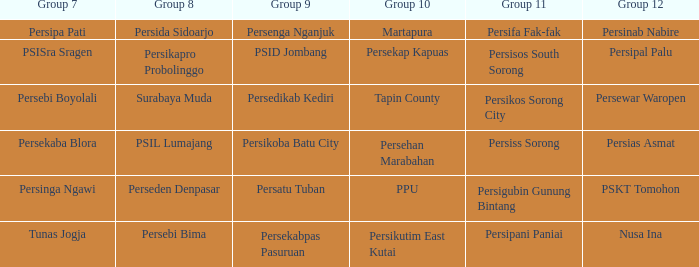Who played in group 11 when Persipal Palu played in group 12? Persisos South Sorong. 